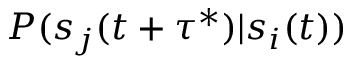Convert formula to latex. <formula><loc_0><loc_0><loc_500><loc_500>P ( s _ { j } ( t + \tau ^ { * } ) | s _ { i } ( t ) )</formula> 